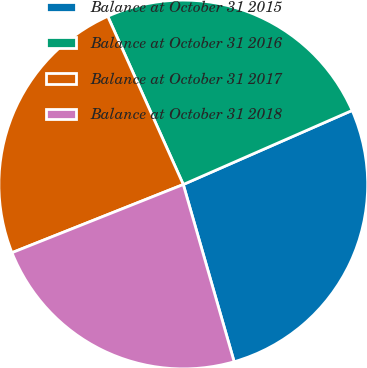Convert chart to OTSL. <chart><loc_0><loc_0><loc_500><loc_500><pie_chart><fcel>Balance at October 31 2015<fcel>Balance at October 31 2016<fcel>Balance at October 31 2017<fcel>Balance at October 31 2018<nl><fcel>27.13%<fcel>25.14%<fcel>24.31%<fcel>23.42%<nl></chart> 